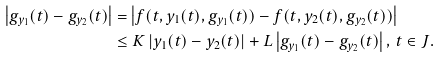<formula> <loc_0><loc_0><loc_500><loc_500>\left | g _ { y _ { 1 } } ( t ) - g _ { y _ { 2 } } ( t ) \right | & = \left | f ( t , y _ { 1 } ( t ) , g _ { y _ { 1 } } ( t ) ) - f ( t , y _ { 2 } ( t ) , g _ { y _ { 2 } } ( t ) ) \right | \\ & \leq K \left | y _ { 1 } ( t ) - y _ { 2 } ( t ) \right | + L \left | g _ { y _ { 1 } } ( t ) - g _ { y _ { 2 } } ( t ) \right | , \, t \in J .</formula> 